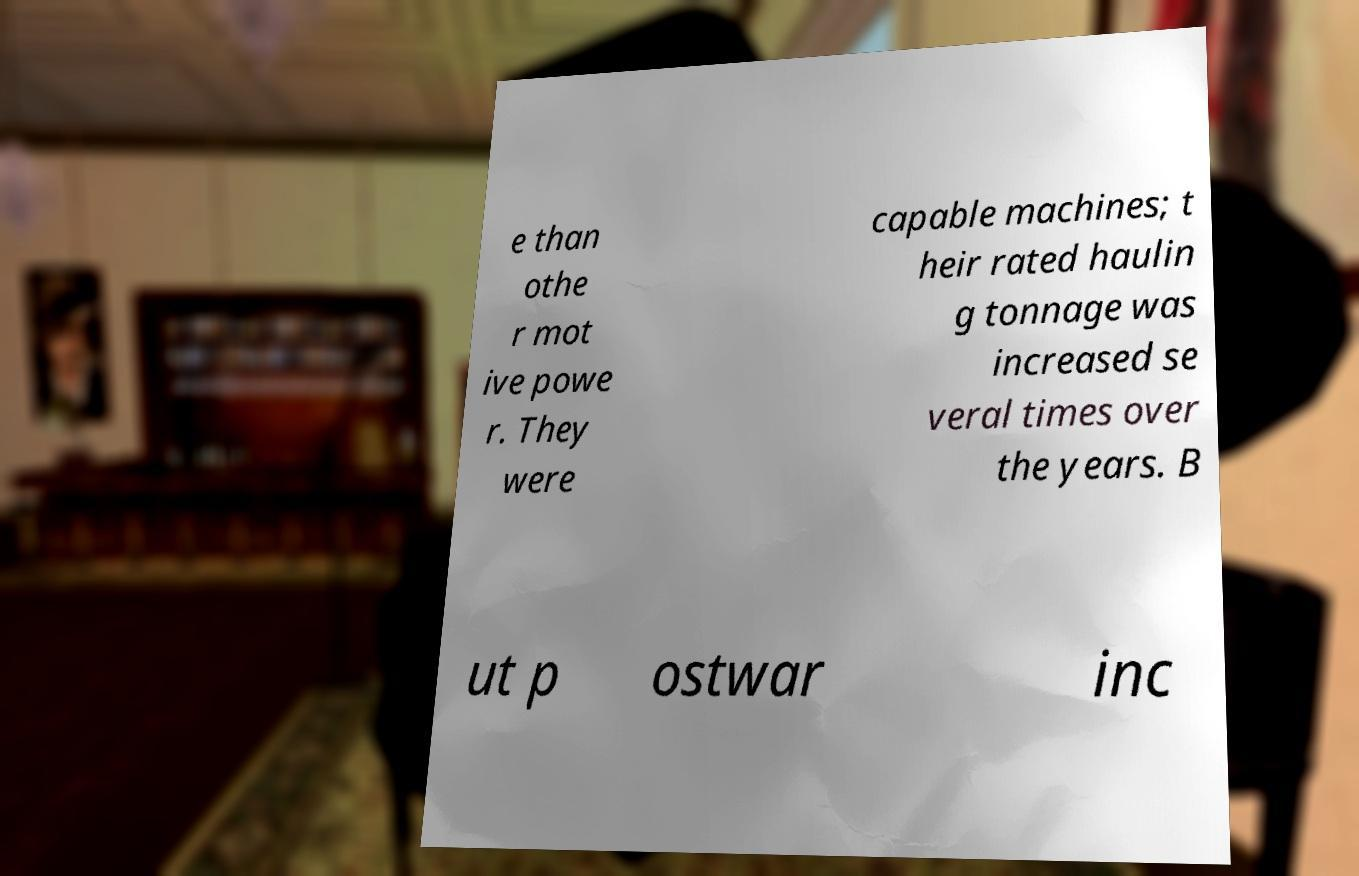I need the written content from this picture converted into text. Can you do that? e than othe r mot ive powe r. They were capable machines; t heir rated haulin g tonnage was increased se veral times over the years. B ut p ostwar inc 